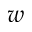Convert formula to latex. <formula><loc_0><loc_0><loc_500><loc_500>w</formula> 